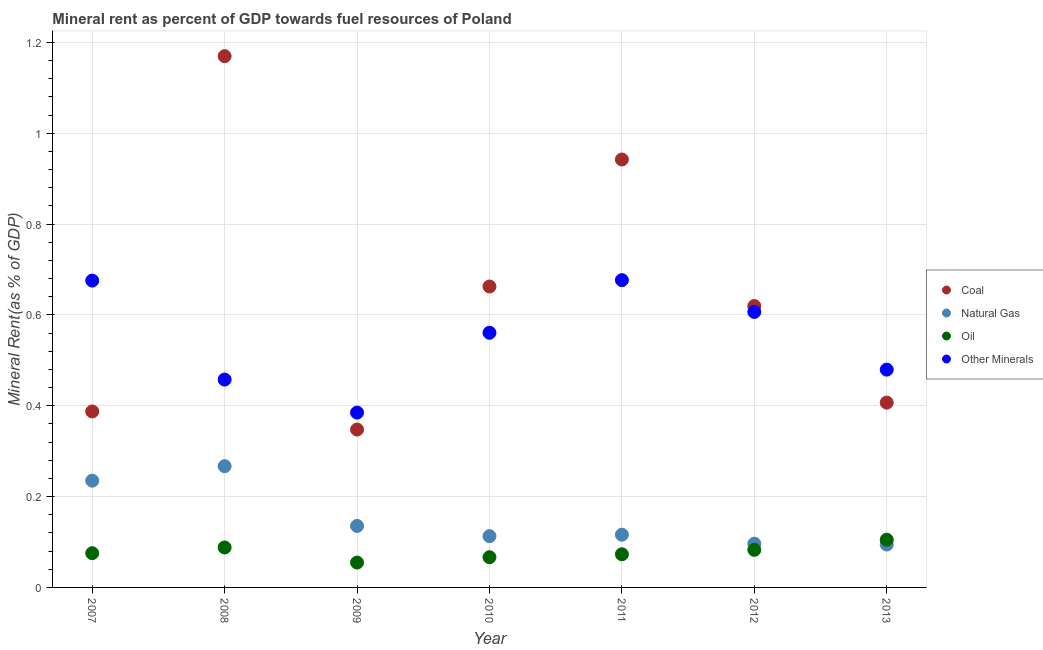How many different coloured dotlines are there?
Provide a short and direct response. 4. Is the number of dotlines equal to the number of legend labels?
Provide a succinct answer. Yes. What is the coal rent in 2007?
Provide a short and direct response. 0.39. Across all years, what is the maximum  rent of other minerals?
Provide a short and direct response. 0.68. Across all years, what is the minimum  rent of other minerals?
Provide a short and direct response. 0.39. In which year was the oil rent minimum?
Provide a succinct answer. 2009. What is the total oil rent in the graph?
Your answer should be compact. 0.55. What is the difference between the coal rent in 2010 and that in 2013?
Make the answer very short. 0.26. What is the difference between the  rent of other minerals in 2007 and the oil rent in 2012?
Offer a terse response. 0.59. What is the average oil rent per year?
Your response must be concise. 0.08. In the year 2007, what is the difference between the oil rent and coal rent?
Give a very brief answer. -0.31. In how many years, is the natural gas rent greater than 0.36 %?
Provide a short and direct response. 0. What is the ratio of the coal rent in 2008 to that in 2012?
Give a very brief answer. 1.89. What is the difference between the highest and the second highest natural gas rent?
Offer a terse response. 0.03. What is the difference between the highest and the lowest oil rent?
Your answer should be very brief. 0.05. In how many years, is the oil rent greater than the average oil rent taken over all years?
Your answer should be compact. 3. Is the sum of the  rent of other minerals in 2010 and 2011 greater than the maximum natural gas rent across all years?
Keep it short and to the point. Yes. Is it the case that in every year, the sum of the coal rent and natural gas rent is greater than the oil rent?
Keep it short and to the point. Yes. Does the coal rent monotonically increase over the years?
Ensure brevity in your answer.  No. Is the  rent of other minerals strictly greater than the coal rent over the years?
Make the answer very short. No. How many years are there in the graph?
Offer a very short reply. 7. Does the graph contain any zero values?
Your answer should be very brief. No. What is the title of the graph?
Your answer should be very brief. Mineral rent as percent of GDP towards fuel resources of Poland. Does "Quality Certification" appear as one of the legend labels in the graph?
Provide a short and direct response. No. What is the label or title of the Y-axis?
Ensure brevity in your answer.  Mineral Rent(as % of GDP). What is the Mineral Rent(as % of GDP) in Coal in 2007?
Your response must be concise. 0.39. What is the Mineral Rent(as % of GDP) of Natural Gas in 2007?
Your answer should be compact. 0.24. What is the Mineral Rent(as % of GDP) of Oil in 2007?
Give a very brief answer. 0.08. What is the Mineral Rent(as % of GDP) of Other Minerals in 2007?
Ensure brevity in your answer.  0.68. What is the Mineral Rent(as % of GDP) in Coal in 2008?
Provide a short and direct response. 1.17. What is the Mineral Rent(as % of GDP) of Natural Gas in 2008?
Offer a terse response. 0.27. What is the Mineral Rent(as % of GDP) of Oil in 2008?
Your response must be concise. 0.09. What is the Mineral Rent(as % of GDP) in Other Minerals in 2008?
Provide a succinct answer. 0.46. What is the Mineral Rent(as % of GDP) of Coal in 2009?
Offer a terse response. 0.35. What is the Mineral Rent(as % of GDP) of Natural Gas in 2009?
Keep it short and to the point. 0.14. What is the Mineral Rent(as % of GDP) of Oil in 2009?
Offer a terse response. 0.05. What is the Mineral Rent(as % of GDP) in Other Minerals in 2009?
Ensure brevity in your answer.  0.39. What is the Mineral Rent(as % of GDP) of Coal in 2010?
Provide a short and direct response. 0.66. What is the Mineral Rent(as % of GDP) in Natural Gas in 2010?
Make the answer very short. 0.11. What is the Mineral Rent(as % of GDP) in Oil in 2010?
Your response must be concise. 0.07. What is the Mineral Rent(as % of GDP) of Other Minerals in 2010?
Provide a short and direct response. 0.56. What is the Mineral Rent(as % of GDP) in Coal in 2011?
Provide a short and direct response. 0.94. What is the Mineral Rent(as % of GDP) in Natural Gas in 2011?
Your answer should be very brief. 0.12. What is the Mineral Rent(as % of GDP) of Oil in 2011?
Offer a very short reply. 0.07. What is the Mineral Rent(as % of GDP) of Other Minerals in 2011?
Ensure brevity in your answer.  0.68. What is the Mineral Rent(as % of GDP) of Coal in 2012?
Offer a very short reply. 0.62. What is the Mineral Rent(as % of GDP) in Natural Gas in 2012?
Keep it short and to the point. 0.1. What is the Mineral Rent(as % of GDP) of Oil in 2012?
Provide a succinct answer. 0.08. What is the Mineral Rent(as % of GDP) of Other Minerals in 2012?
Your response must be concise. 0.61. What is the Mineral Rent(as % of GDP) of Coal in 2013?
Your response must be concise. 0.41. What is the Mineral Rent(as % of GDP) of Natural Gas in 2013?
Make the answer very short. 0.09. What is the Mineral Rent(as % of GDP) of Oil in 2013?
Provide a succinct answer. 0.11. What is the Mineral Rent(as % of GDP) in Other Minerals in 2013?
Offer a very short reply. 0.48. Across all years, what is the maximum Mineral Rent(as % of GDP) in Coal?
Give a very brief answer. 1.17. Across all years, what is the maximum Mineral Rent(as % of GDP) in Natural Gas?
Offer a terse response. 0.27. Across all years, what is the maximum Mineral Rent(as % of GDP) in Oil?
Your response must be concise. 0.11. Across all years, what is the maximum Mineral Rent(as % of GDP) of Other Minerals?
Offer a very short reply. 0.68. Across all years, what is the minimum Mineral Rent(as % of GDP) of Coal?
Offer a very short reply. 0.35. Across all years, what is the minimum Mineral Rent(as % of GDP) in Natural Gas?
Give a very brief answer. 0.09. Across all years, what is the minimum Mineral Rent(as % of GDP) in Oil?
Give a very brief answer. 0.05. Across all years, what is the minimum Mineral Rent(as % of GDP) in Other Minerals?
Make the answer very short. 0.39. What is the total Mineral Rent(as % of GDP) of Coal in the graph?
Make the answer very short. 4.54. What is the total Mineral Rent(as % of GDP) of Natural Gas in the graph?
Your answer should be compact. 1.06. What is the total Mineral Rent(as % of GDP) of Oil in the graph?
Your response must be concise. 0.55. What is the total Mineral Rent(as % of GDP) in Other Minerals in the graph?
Your answer should be very brief. 3.84. What is the difference between the Mineral Rent(as % of GDP) in Coal in 2007 and that in 2008?
Your answer should be very brief. -0.78. What is the difference between the Mineral Rent(as % of GDP) in Natural Gas in 2007 and that in 2008?
Offer a very short reply. -0.03. What is the difference between the Mineral Rent(as % of GDP) in Oil in 2007 and that in 2008?
Offer a very short reply. -0.01. What is the difference between the Mineral Rent(as % of GDP) in Other Minerals in 2007 and that in 2008?
Give a very brief answer. 0.22. What is the difference between the Mineral Rent(as % of GDP) of Coal in 2007 and that in 2009?
Provide a short and direct response. 0.04. What is the difference between the Mineral Rent(as % of GDP) in Natural Gas in 2007 and that in 2009?
Provide a succinct answer. 0.1. What is the difference between the Mineral Rent(as % of GDP) of Oil in 2007 and that in 2009?
Offer a terse response. 0.02. What is the difference between the Mineral Rent(as % of GDP) in Other Minerals in 2007 and that in 2009?
Offer a very short reply. 0.29. What is the difference between the Mineral Rent(as % of GDP) of Coal in 2007 and that in 2010?
Your answer should be compact. -0.28. What is the difference between the Mineral Rent(as % of GDP) of Natural Gas in 2007 and that in 2010?
Your answer should be very brief. 0.12. What is the difference between the Mineral Rent(as % of GDP) in Oil in 2007 and that in 2010?
Make the answer very short. 0.01. What is the difference between the Mineral Rent(as % of GDP) in Other Minerals in 2007 and that in 2010?
Your answer should be very brief. 0.11. What is the difference between the Mineral Rent(as % of GDP) in Coal in 2007 and that in 2011?
Your answer should be compact. -0.55. What is the difference between the Mineral Rent(as % of GDP) in Natural Gas in 2007 and that in 2011?
Your answer should be compact. 0.12. What is the difference between the Mineral Rent(as % of GDP) of Oil in 2007 and that in 2011?
Ensure brevity in your answer.  0. What is the difference between the Mineral Rent(as % of GDP) in Other Minerals in 2007 and that in 2011?
Provide a short and direct response. -0. What is the difference between the Mineral Rent(as % of GDP) in Coal in 2007 and that in 2012?
Your response must be concise. -0.23. What is the difference between the Mineral Rent(as % of GDP) in Natural Gas in 2007 and that in 2012?
Your answer should be very brief. 0.14. What is the difference between the Mineral Rent(as % of GDP) in Oil in 2007 and that in 2012?
Make the answer very short. -0.01. What is the difference between the Mineral Rent(as % of GDP) of Other Minerals in 2007 and that in 2012?
Keep it short and to the point. 0.07. What is the difference between the Mineral Rent(as % of GDP) in Coal in 2007 and that in 2013?
Ensure brevity in your answer.  -0.02. What is the difference between the Mineral Rent(as % of GDP) in Natural Gas in 2007 and that in 2013?
Your response must be concise. 0.14. What is the difference between the Mineral Rent(as % of GDP) in Oil in 2007 and that in 2013?
Offer a terse response. -0.03. What is the difference between the Mineral Rent(as % of GDP) in Other Minerals in 2007 and that in 2013?
Offer a terse response. 0.2. What is the difference between the Mineral Rent(as % of GDP) of Coal in 2008 and that in 2009?
Provide a short and direct response. 0.82. What is the difference between the Mineral Rent(as % of GDP) in Natural Gas in 2008 and that in 2009?
Make the answer very short. 0.13. What is the difference between the Mineral Rent(as % of GDP) of Oil in 2008 and that in 2009?
Ensure brevity in your answer.  0.03. What is the difference between the Mineral Rent(as % of GDP) of Other Minerals in 2008 and that in 2009?
Keep it short and to the point. 0.07. What is the difference between the Mineral Rent(as % of GDP) of Coal in 2008 and that in 2010?
Make the answer very short. 0.51. What is the difference between the Mineral Rent(as % of GDP) in Natural Gas in 2008 and that in 2010?
Your answer should be very brief. 0.15. What is the difference between the Mineral Rent(as % of GDP) in Oil in 2008 and that in 2010?
Give a very brief answer. 0.02. What is the difference between the Mineral Rent(as % of GDP) in Other Minerals in 2008 and that in 2010?
Keep it short and to the point. -0.1. What is the difference between the Mineral Rent(as % of GDP) in Coal in 2008 and that in 2011?
Give a very brief answer. 0.23. What is the difference between the Mineral Rent(as % of GDP) of Natural Gas in 2008 and that in 2011?
Give a very brief answer. 0.15. What is the difference between the Mineral Rent(as % of GDP) of Oil in 2008 and that in 2011?
Provide a succinct answer. 0.01. What is the difference between the Mineral Rent(as % of GDP) in Other Minerals in 2008 and that in 2011?
Ensure brevity in your answer.  -0.22. What is the difference between the Mineral Rent(as % of GDP) in Coal in 2008 and that in 2012?
Ensure brevity in your answer.  0.55. What is the difference between the Mineral Rent(as % of GDP) of Natural Gas in 2008 and that in 2012?
Give a very brief answer. 0.17. What is the difference between the Mineral Rent(as % of GDP) of Oil in 2008 and that in 2012?
Keep it short and to the point. 0.01. What is the difference between the Mineral Rent(as % of GDP) of Other Minerals in 2008 and that in 2012?
Your answer should be very brief. -0.15. What is the difference between the Mineral Rent(as % of GDP) in Coal in 2008 and that in 2013?
Your answer should be compact. 0.76. What is the difference between the Mineral Rent(as % of GDP) of Natural Gas in 2008 and that in 2013?
Your answer should be compact. 0.17. What is the difference between the Mineral Rent(as % of GDP) in Oil in 2008 and that in 2013?
Offer a very short reply. -0.02. What is the difference between the Mineral Rent(as % of GDP) in Other Minerals in 2008 and that in 2013?
Provide a succinct answer. -0.02. What is the difference between the Mineral Rent(as % of GDP) in Coal in 2009 and that in 2010?
Your answer should be very brief. -0.32. What is the difference between the Mineral Rent(as % of GDP) of Natural Gas in 2009 and that in 2010?
Your answer should be compact. 0.02. What is the difference between the Mineral Rent(as % of GDP) in Oil in 2009 and that in 2010?
Provide a succinct answer. -0.01. What is the difference between the Mineral Rent(as % of GDP) of Other Minerals in 2009 and that in 2010?
Provide a succinct answer. -0.18. What is the difference between the Mineral Rent(as % of GDP) in Coal in 2009 and that in 2011?
Make the answer very short. -0.59. What is the difference between the Mineral Rent(as % of GDP) of Natural Gas in 2009 and that in 2011?
Your answer should be very brief. 0.02. What is the difference between the Mineral Rent(as % of GDP) in Oil in 2009 and that in 2011?
Your response must be concise. -0.02. What is the difference between the Mineral Rent(as % of GDP) of Other Minerals in 2009 and that in 2011?
Give a very brief answer. -0.29. What is the difference between the Mineral Rent(as % of GDP) in Coal in 2009 and that in 2012?
Offer a very short reply. -0.27. What is the difference between the Mineral Rent(as % of GDP) in Natural Gas in 2009 and that in 2012?
Keep it short and to the point. 0.04. What is the difference between the Mineral Rent(as % of GDP) of Oil in 2009 and that in 2012?
Your answer should be very brief. -0.03. What is the difference between the Mineral Rent(as % of GDP) in Other Minerals in 2009 and that in 2012?
Offer a very short reply. -0.22. What is the difference between the Mineral Rent(as % of GDP) in Coal in 2009 and that in 2013?
Give a very brief answer. -0.06. What is the difference between the Mineral Rent(as % of GDP) of Natural Gas in 2009 and that in 2013?
Provide a succinct answer. 0.04. What is the difference between the Mineral Rent(as % of GDP) of Oil in 2009 and that in 2013?
Provide a short and direct response. -0.05. What is the difference between the Mineral Rent(as % of GDP) of Other Minerals in 2009 and that in 2013?
Keep it short and to the point. -0.09. What is the difference between the Mineral Rent(as % of GDP) in Coal in 2010 and that in 2011?
Provide a succinct answer. -0.28. What is the difference between the Mineral Rent(as % of GDP) of Natural Gas in 2010 and that in 2011?
Your answer should be very brief. -0. What is the difference between the Mineral Rent(as % of GDP) of Oil in 2010 and that in 2011?
Give a very brief answer. -0.01. What is the difference between the Mineral Rent(as % of GDP) in Other Minerals in 2010 and that in 2011?
Offer a terse response. -0.12. What is the difference between the Mineral Rent(as % of GDP) of Coal in 2010 and that in 2012?
Offer a terse response. 0.04. What is the difference between the Mineral Rent(as % of GDP) in Natural Gas in 2010 and that in 2012?
Make the answer very short. 0.02. What is the difference between the Mineral Rent(as % of GDP) in Oil in 2010 and that in 2012?
Offer a terse response. -0.02. What is the difference between the Mineral Rent(as % of GDP) in Other Minerals in 2010 and that in 2012?
Offer a very short reply. -0.05. What is the difference between the Mineral Rent(as % of GDP) in Coal in 2010 and that in 2013?
Offer a very short reply. 0.26. What is the difference between the Mineral Rent(as % of GDP) in Natural Gas in 2010 and that in 2013?
Your answer should be very brief. 0.02. What is the difference between the Mineral Rent(as % of GDP) of Oil in 2010 and that in 2013?
Give a very brief answer. -0.04. What is the difference between the Mineral Rent(as % of GDP) in Other Minerals in 2010 and that in 2013?
Your answer should be very brief. 0.08. What is the difference between the Mineral Rent(as % of GDP) in Coal in 2011 and that in 2012?
Your answer should be very brief. 0.32. What is the difference between the Mineral Rent(as % of GDP) of Natural Gas in 2011 and that in 2012?
Make the answer very short. 0.02. What is the difference between the Mineral Rent(as % of GDP) of Oil in 2011 and that in 2012?
Ensure brevity in your answer.  -0.01. What is the difference between the Mineral Rent(as % of GDP) of Other Minerals in 2011 and that in 2012?
Keep it short and to the point. 0.07. What is the difference between the Mineral Rent(as % of GDP) of Coal in 2011 and that in 2013?
Make the answer very short. 0.54. What is the difference between the Mineral Rent(as % of GDP) of Natural Gas in 2011 and that in 2013?
Your response must be concise. 0.02. What is the difference between the Mineral Rent(as % of GDP) in Oil in 2011 and that in 2013?
Your response must be concise. -0.03. What is the difference between the Mineral Rent(as % of GDP) in Other Minerals in 2011 and that in 2013?
Your response must be concise. 0.2. What is the difference between the Mineral Rent(as % of GDP) in Coal in 2012 and that in 2013?
Your answer should be compact. 0.21. What is the difference between the Mineral Rent(as % of GDP) in Natural Gas in 2012 and that in 2013?
Your answer should be very brief. 0. What is the difference between the Mineral Rent(as % of GDP) in Oil in 2012 and that in 2013?
Keep it short and to the point. -0.02. What is the difference between the Mineral Rent(as % of GDP) in Other Minerals in 2012 and that in 2013?
Offer a terse response. 0.13. What is the difference between the Mineral Rent(as % of GDP) of Coal in 2007 and the Mineral Rent(as % of GDP) of Natural Gas in 2008?
Provide a succinct answer. 0.12. What is the difference between the Mineral Rent(as % of GDP) of Coal in 2007 and the Mineral Rent(as % of GDP) of Oil in 2008?
Make the answer very short. 0.3. What is the difference between the Mineral Rent(as % of GDP) in Coal in 2007 and the Mineral Rent(as % of GDP) in Other Minerals in 2008?
Provide a succinct answer. -0.07. What is the difference between the Mineral Rent(as % of GDP) of Natural Gas in 2007 and the Mineral Rent(as % of GDP) of Oil in 2008?
Give a very brief answer. 0.15. What is the difference between the Mineral Rent(as % of GDP) of Natural Gas in 2007 and the Mineral Rent(as % of GDP) of Other Minerals in 2008?
Offer a terse response. -0.22. What is the difference between the Mineral Rent(as % of GDP) in Oil in 2007 and the Mineral Rent(as % of GDP) in Other Minerals in 2008?
Ensure brevity in your answer.  -0.38. What is the difference between the Mineral Rent(as % of GDP) of Coal in 2007 and the Mineral Rent(as % of GDP) of Natural Gas in 2009?
Make the answer very short. 0.25. What is the difference between the Mineral Rent(as % of GDP) in Coal in 2007 and the Mineral Rent(as % of GDP) in Oil in 2009?
Provide a short and direct response. 0.33. What is the difference between the Mineral Rent(as % of GDP) in Coal in 2007 and the Mineral Rent(as % of GDP) in Other Minerals in 2009?
Your answer should be compact. 0. What is the difference between the Mineral Rent(as % of GDP) of Natural Gas in 2007 and the Mineral Rent(as % of GDP) of Oil in 2009?
Offer a terse response. 0.18. What is the difference between the Mineral Rent(as % of GDP) of Natural Gas in 2007 and the Mineral Rent(as % of GDP) of Other Minerals in 2009?
Your answer should be very brief. -0.15. What is the difference between the Mineral Rent(as % of GDP) in Oil in 2007 and the Mineral Rent(as % of GDP) in Other Minerals in 2009?
Your response must be concise. -0.31. What is the difference between the Mineral Rent(as % of GDP) of Coal in 2007 and the Mineral Rent(as % of GDP) of Natural Gas in 2010?
Ensure brevity in your answer.  0.27. What is the difference between the Mineral Rent(as % of GDP) of Coal in 2007 and the Mineral Rent(as % of GDP) of Oil in 2010?
Your answer should be very brief. 0.32. What is the difference between the Mineral Rent(as % of GDP) in Coal in 2007 and the Mineral Rent(as % of GDP) in Other Minerals in 2010?
Make the answer very short. -0.17. What is the difference between the Mineral Rent(as % of GDP) in Natural Gas in 2007 and the Mineral Rent(as % of GDP) in Oil in 2010?
Ensure brevity in your answer.  0.17. What is the difference between the Mineral Rent(as % of GDP) of Natural Gas in 2007 and the Mineral Rent(as % of GDP) of Other Minerals in 2010?
Keep it short and to the point. -0.33. What is the difference between the Mineral Rent(as % of GDP) of Oil in 2007 and the Mineral Rent(as % of GDP) of Other Minerals in 2010?
Your answer should be compact. -0.49. What is the difference between the Mineral Rent(as % of GDP) in Coal in 2007 and the Mineral Rent(as % of GDP) in Natural Gas in 2011?
Give a very brief answer. 0.27. What is the difference between the Mineral Rent(as % of GDP) of Coal in 2007 and the Mineral Rent(as % of GDP) of Oil in 2011?
Give a very brief answer. 0.31. What is the difference between the Mineral Rent(as % of GDP) in Coal in 2007 and the Mineral Rent(as % of GDP) in Other Minerals in 2011?
Your answer should be compact. -0.29. What is the difference between the Mineral Rent(as % of GDP) of Natural Gas in 2007 and the Mineral Rent(as % of GDP) of Oil in 2011?
Your answer should be very brief. 0.16. What is the difference between the Mineral Rent(as % of GDP) of Natural Gas in 2007 and the Mineral Rent(as % of GDP) of Other Minerals in 2011?
Provide a short and direct response. -0.44. What is the difference between the Mineral Rent(as % of GDP) of Oil in 2007 and the Mineral Rent(as % of GDP) of Other Minerals in 2011?
Keep it short and to the point. -0.6. What is the difference between the Mineral Rent(as % of GDP) of Coal in 2007 and the Mineral Rent(as % of GDP) of Natural Gas in 2012?
Ensure brevity in your answer.  0.29. What is the difference between the Mineral Rent(as % of GDP) in Coal in 2007 and the Mineral Rent(as % of GDP) in Oil in 2012?
Keep it short and to the point. 0.3. What is the difference between the Mineral Rent(as % of GDP) in Coal in 2007 and the Mineral Rent(as % of GDP) in Other Minerals in 2012?
Provide a succinct answer. -0.22. What is the difference between the Mineral Rent(as % of GDP) in Natural Gas in 2007 and the Mineral Rent(as % of GDP) in Oil in 2012?
Offer a terse response. 0.15. What is the difference between the Mineral Rent(as % of GDP) of Natural Gas in 2007 and the Mineral Rent(as % of GDP) of Other Minerals in 2012?
Your answer should be very brief. -0.37. What is the difference between the Mineral Rent(as % of GDP) of Oil in 2007 and the Mineral Rent(as % of GDP) of Other Minerals in 2012?
Provide a short and direct response. -0.53. What is the difference between the Mineral Rent(as % of GDP) of Coal in 2007 and the Mineral Rent(as % of GDP) of Natural Gas in 2013?
Provide a succinct answer. 0.29. What is the difference between the Mineral Rent(as % of GDP) of Coal in 2007 and the Mineral Rent(as % of GDP) of Oil in 2013?
Make the answer very short. 0.28. What is the difference between the Mineral Rent(as % of GDP) in Coal in 2007 and the Mineral Rent(as % of GDP) in Other Minerals in 2013?
Your response must be concise. -0.09. What is the difference between the Mineral Rent(as % of GDP) in Natural Gas in 2007 and the Mineral Rent(as % of GDP) in Oil in 2013?
Make the answer very short. 0.13. What is the difference between the Mineral Rent(as % of GDP) of Natural Gas in 2007 and the Mineral Rent(as % of GDP) of Other Minerals in 2013?
Give a very brief answer. -0.24. What is the difference between the Mineral Rent(as % of GDP) of Oil in 2007 and the Mineral Rent(as % of GDP) of Other Minerals in 2013?
Provide a short and direct response. -0.4. What is the difference between the Mineral Rent(as % of GDP) in Coal in 2008 and the Mineral Rent(as % of GDP) in Natural Gas in 2009?
Provide a short and direct response. 1.03. What is the difference between the Mineral Rent(as % of GDP) in Coal in 2008 and the Mineral Rent(as % of GDP) in Oil in 2009?
Your answer should be compact. 1.12. What is the difference between the Mineral Rent(as % of GDP) of Coal in 2008 and the Mineral Rent(as % of GDP) of Other Minerals in 2009?
Offer a terse response. 0.78. What is the difference between the Mineral Rent(as % of GDP) in Natural Gas in 2008 and the Mineral Rent(as % of GDP) in Oil in 2009?
Keep it short and to the point. 0.21. What is the difference between the Mineral Rent(as % of GDP) in Natural Gas in 2008 and the Mineral Rent(as % of GDP) in Other Minerals in 2009?
Your answer should be compact. -0.12. What is the difference between the Mineral Rent(as % of GDP) of Oil in 2008 and the Mineral Rent(as % of GDP) of Other Minerals in 2009?
Your response must be concise. -0.3. What is the difference between the Mineral Rent(as % of GDP) of Coal in 2008 and the Mineral Rent(as % of GDP) of Natural Gas in 2010?
Your response must be concise. 1.06. What is the difference between the Mineral Rent(as % of GDP) in Coal in 2008 and the Mineral Rent(as % of GDP) in Oil in 2010?
Ensure brevity in your answer.  1.1. What is the difference between the Mineral Rent(as % of GDP) in Coal in 2008 and the Mineral Rent(as % of GDP) in Other Minerals in 2010?
Ensure brevity in your answer.  0.61. What is the difference between the Mineral Rent(as % of GDP) in Natural Gas in 2008 and the Mineral Rent(as % of GDP) in Oil in 2010?
Offer a very short reply. 0.2. What is the difference between the Mineral Rent(as % of GDP) in Natural Gas in 2008 and the Mineral Rent(as % of GDP) in Other Minerals in 2010?
Your answer should be very brief. -0.29. What is the difference between the Mineral Rent(as % of GDP) of Oil in 2008 and the Mineral Rent(as % of GDP) of Other Minerals in 2010?
Your response must be concise. -0.47. What is the difference between the Mineral Rent(as % of GDP) of Coal in 2008 and the Mineral Rent(as % of GDP) of Natural Gas in 2011?
Give a very brief answer. 1.05. What is the difference between the Mineral Rent(as % of GDP) in Coal in 2008 and the Mineral Rent(as % of GDP) in Oil in 2011?
Keep it short and to the point. 1.1. What is the difference between the Mineral Rent(as % of GDP) of Coal in 2008 and the Mineral Rent(as % of GDP) of Other Minerals in 2011?
Provide a short and direct response. 0.49. What is the difference between the Mineral Rent(as % of GDP) in Natural Gas in 2008 and the Mineral Rent(as % of GDP) in Oil in 2011?
Your response must be concise. 0.19. What is the difference between the Mineral Rent(as % of GDP) of Natural Gas in 2008 and the Mineral Rent(as % of GDP) of Other Minerals in 2011?
Ensure brevity in your answer.  -0.41. What is the difference between the Mineral Rent(as % of GDP) of Oil in 2008 and the Mineral Rent(as % of GDP) of Other Minerals in 2011?
Give a very brief answer. -0.59. What is the difference between the Mineral Rent(as % of GDP) in Coal in 2008 and the Mineral Rent(as % of GDP) in Natural Gas in 2012?
Provide a succinct answer. 1.07. What is the difference between the Mineral Rent(as % of GDP) of Coal in 2008 and the Mineral Rent(as % of GDP) of Oil in 2012?
Keep it short and to the point. 1.09. What is the difference between the Mineral Rent(as % of GDP) in Coal in 2008 and the Mineral Rent(as % of GDP) in Other Minerals in 2012?
Offer a very short reply. 0.56. What is the difference between the Mineral Rent(as % of GDP) of Natural Gas in 2008 and the Mineral Rent(as % of GDP) of Oil in 2012?
Ensure brevity in your answer.  0.18. What is the difference between the Mineral Rent(as % of GDP) in Natural Gas in 2008 and the Mineral Rent(as % of GDP) in Other Minerals in 2012?
Your response must be concise. -0.34. What is the difference between the Mineral Rent(as % of GDP) of Oil in 2008 and the Mineral Rent(as % of GDP) of Other Minerals in 2012?
Make the answer very short. -0.52. What is the difference between the Mineral Rent(as % of GDP) in Coal in 2008 and the Mineral Rent(as % of GDP) in Natural Gas in 2013?
Make the answer very short. 1.08. What is the difference between the Mineral Rent(as % of GDP) in Coal in 2008 and the Mineral Rent(as % of GDP) in Oil in 2013?
Give a very brief answer. 1.06. What is the difference between the Mineral Rent(as % of GDP) in Coal in 2008 and the Mineral Rent(as % of GDP) in Other Minerals in 2013?
Offer a very short reply. 0.69. What is the difference between the Mineral Rent(as % of GDP) of Natural Gas in 2008 and the Mineral Rent(as % of GDP) of Oil in 2013?
Provide a succinct answer. 0.16. What is the difference between the Mineral Rent(as % of GDP) of Natural Gas in 2008 and the Mineral Rent(as % of GDP) of Other Minerals in 2013?
Give a very brief answer. -0.21. What is the difference between the Mineral Rent(as % of GDP) of Oil in 2008 and the Mineral Rent(as % of GDP) of Other Minerals in 2013?
Offer a terse response. -0.39. What is the difference between the Mineral Rent(as % of GDP) of Coal in 2009 and the Mineral Rent(as % of GDP) of Natural Gas in 2010?
Provide a succinct answer. 0.23. What is the difference between the Mineral Rent(as % of GDP) of Coal in 2009 and the Mineral Rent(as % of GDP) of Oil in 2010?
Your answer should be compact. 0.28. What is the difference between the Mineral Rent(as % of GDP) in Coal in 2009 and the Mineral Rent(as % of GDP) in Other Minerals in 2010?
Give a very brief answer. -0.21. What is the difference between the Mineral Rent(as % of GDP) in Natural Gas in 2009 and the Mineral Rent(as % of GDP) in Oil in 2010?
Keep it short and to the point. 0.07. What is the difference between the Mineral Rent(as % of GDP) in Natural Gas in 2009 and the Mineral Rent(as % of GDP) in Other Minerals in 2010?
Provide a succinct answer. -0.43. What is the difference between the Mineral Rent(as % of GDP) of Oil in 2009 and the Mineral Rent(as % of GDP) of Other Minerals in 2010?
Provide a succinct answer. -0.51. What is the difference between the Mineral Rent(as % of GDP) in Coal in 2009 and the Mineral Rent(as % of GDP) in Natural Gas in 2011?
Keep it short and to the point. 0.23. What is the difference between the Mineral Rent(as % of GDP) of Coal in 2009 and the Mineral Rent(as % of GDP) of Oil in 2011?
Offer a very short reply. 0.27. What is the difference between the Mineral Rent(as % of GDP) of Coal in 2009 and the Mineral Rent(as % of GDP) of Other Minerals in 2011?
Ensure brevity in your answer.  -0.33. What is the difference between the Mineral Rent(as % of GDP) of Natural Gas in 2009 and the Mineral Rent(as % of GDP) of Oil in 2011?
Provide a short and direct response. 0.06. What is the difference between the Mineral Rent(as % of GDP) in Natural Gas in 2009 and the Mineral Rent(as % of GDP) in Other Minerals in 2011?
Ensure brevity in your answer.  -0.54. What is the difference between the Mineral Rent(as % of GDP) in Oil in 2009 and the Mineral Rent(as % of GDP) in Other Minerals in 2011?
Give a very brief answer. -0.62. What is the difference between the Mineral Rent(as % of GDP) of Coal in 2009 and the Mineral Rent(as % of GDP) of Natural Gas in 2012?
Offer a terse response. 0.25. What is the difference between the Mineral Rent(as % of GDP) in Coal in 2009 and the Mineral Rent(as % of GDP) in Oil in 2012?
Give a very brief answer. 0.26. What is the difference between the Mineral Rent(as % of GDP) of Coal in 2009 and the Mineral Rent(as % of GDP) of Other Minerals in 2012?
Ensure brevity in your answer.  -0.26. What is the difference between the Mineral Rent(as % of GDP) of Natural Gas in 2009 and the Mineral Rent(as % of GDP) of Oil in 2012?
Your response must be concise. 0.05. What is the difference between the Mineral Rent(as % of GDP) in Natural Gas in 2009 and the Mineral Rent(as % of GDP) in Other Minerals in 2012?
Provide a succinct answer. -0.47. What is the difference between the Mineral Rent(as % of GDP) of Oil in 2009 and the Mineral Rent(as % of GDP) of Other Minerals in 2012?
Give a very brief answer. -0.55. What is the difference between the Mineral Rent(as % of GDP) of Coal in 2009 and the Mineral Rent(as % of GDP) of Natural Gas in 2013?
Keep it short and to the point. 0.25. What is the difference between the Mineral Rent(as % of GDP) in Coal in 2009 and the Mineral Rent(as % of GDP) in Oil in 2013?
Offer a very short reply. 0.24. What is the difference between the Mineral Rent(as % of GDP) of Coal in 2009 and the Mineral Rent(as % of GDP) of Other Minerals in 2013?
Keep it short and to the point. -0.13. What is the difference between the Mineral Rent(as % of GDP) in Natural Gas in 2009 and the Mineral Rent(as % of GDP) in Oil in 2013?
Make the answer very short. 0.03. What is the difference between the Mineral Rent(as % of GDP) in Natural Gas in 2009 and the Mineral Rent(as % of GDP) in Other Minerals in 2013?
Your response must be concise. -0.34. What is the difference between the Mineral Rent(as % of GDP) in Oil in 2009 and the Mineral Rent(as % of GDP) in Other Minerals in 2013?
Your response must be concise. -0.42. What is the difference between the Mineral Rent(as % of GDP) of Coal in 2010 and the Mineral Rent(as % of GDP) of Natural Gas in 2011?
Give a very brief answer. 0.55. What is the difference between the Mineral Rent(as % of GDP) of Coal in 2010 and the Mineral Rent(as % of GDP) of Oil in 2011?
Your answer should be compact. 0.59. What is the difference between the Mineral Rent(as % of GDP) of Coal in 2010 and the Mineral Rent(as % of GDP) of Other Minerals in 2011?
Your response must be concise. -0.01. What is the difference between the Mineral Rent(as % of GDP) of Natural Gas in 2010 and the Mineral Rent(as % of GDP) of Oil in 2011?
Provide a succinct answer. 0.04. What is the difference between the Mineral Rent(as % of GDP) of Natural Gas in 2010 and the Mineral Rent(as % of GDP) of Other Minerals in 2011?
Offer a terse response. -0.56. What is the difference between the Mineral Rent(as % of GDP) of Oil in 2010 and the Mineral Rent(as % of GDP) of Other Minerals in 2011?
Give a very brief answer. -0.61. What is the difference between the Mineral Rent(as % of GDP) in Coal in 2010 and the Mineral Rent(as % of GDP) in Natural Gas in 2012?
Your answer should be compact. 0.57. What is the difference between the Mineral Rent(as % of GDP) in Coal in 2010 and the Mineral Rent(as % of GDP) in Oil in 2012?
Your answer should be very brief. 0.58. What is the difference between the Mineral Rent(as % of GDP) in Coal in 2010 and the Mineral Rent(as % of GDP) in Other Minerals in 2012?
Offer a terse response. 0.06. What is the difference between the Mineral Rent(as % of GDP) of Natural Gas in 2010 and the Mineral Rent(as % of GDP) of Oil in 2012?
Offer a very short reply. 0.03. What is the difference between the Mineral Rent(as % of GDP) of Natural Gas in 2010 and the Mineral Rent(as % of GDP) of Other Minerals in 2012?
Make the answer very short. -0.49. What is the difference between the Mineral Rent(as % of GDP) of Oil in 2010 and the Mineral Rent(as % of GDP) of Other Minerals in 2012?
Offer a terse response. -0.54. What is the difference between the Mineral Rent(as % of GDP) in Coal in 2010 and the Mineral Rent(as % of GDP) in Natural Gas in 2013?
Offer a terse response. 0.57. What is the difference between the Mineral Rent(as % of GDP) of Coal in 2010 and the Mineral Rent(as % of GDP) of Oil in 2013?
Keep it short and to the point. 0.56. What is the difference between the Mineral Rent(as % of GDP) in Coal in 2010 and the Mineral Rent(as % of GDP) in Other Minerals in 2013?
Your answer should be very brief. 0.18. What is the difference between the Mineral Rent(as % of GDP) of Natural Gas in 2010 and the Mineral Rent(as % of GDP) of Oil in 2013?
Make the answer very short. 0.01. What is the difference between the Mineral Rent(as % of GDP) of Natural Gas in 2010 and the Mineral Rent(as % of GDP) of Other Minerals in 2013?
Provide a short and direct response. -0.37. What is the difference between the Mineral Rent(as % of GDP) of Oil in 2010 and the Mineral Rent(as % of GDP) of Other Minerals in 2013?
Offer a terse response. -0.41. What is the difference between the Mineral Rent(as % of GDP) of Coal in 2011 and the Mineral Rent(as % of GDP) of Natural Gas in 2012?
Make the answer very short. 0.85. What is the difference between the Mineral Rent(as % of GDP) in Coal in 2011 and the Mineral Rent(as % of GDP) in Oil in 2012?
Keep it short and to the point. 0.86. What is the difference between the Mineral Rent(as % of GDP) of Coal in 2011 and the Mineral Rent(as % of GDP) of Other Minerals in 2012?
Make the answer very short. 0.34. What is the difference between the Mineral Rent(as % of GDP) in Natural Gas in 2011 and the Mineral Rent(as % of GDP) in Oil in 2012?
Offer a very short reply. 0.03. What is the difference between the Mineral Rent(as % of GDP) in Natural Gas in 2011 and the Mineral Rent(as % of GDP) in Other Minerals in 2012?
Your response must be concise. -0.49. What is the difference between the Mineral Rent(as % of GDP) of Oil in 2011 and the Mineral Rent(as % of GDP) of Other Minerals in 2012?
Your answer should be very brief. -0.53. What is the difference between the Mineral Rent(as % of GDP) of Coal in 2011 and the Mineral Rent(as % of GDP) of Natural Gas in 2013?
Keep it short and to the point. 0.85. What is the difference between the Mineral Rent(as % of GDP) of Coal in 2011 and the Mineral Rent(as % of GDP) of Oil in 2013?
Your response must be concise. 0.84. What is the difference between the Mineral Rent(as % of GDP) in Coal in 2011 and the Mineral Rent(as % of GDP) in Other Minerals in 2013?
Give a very brief answer. 0.46. What is the difference between the Mineral Rent(as % of GDP) in Natural Gas in 2011 and the Mineral Rent(as % of GDP) in Oil in 2013?
Offer a very short reply. 0.01. What is the difference between the Mineral Rent(as % of GDP) in Natural Gas in 2011 and the Mineral Rent(as % of GDP) in Other Minerals in 2013?
Ensure brevity in your answer.  -0.36. What is the difference between the Mineral Rent(as % of GDP) in Oil in 2011 and the Mineral Rent(as % of GDP) in Other Minerals in 2013?
Ensure brevity in your answer.  -0.41. What is the difference between the Mineral Rent(as % of GDP) in Coal in 2012 and the Mineral Rent(as % of GDP) in Natural Gas in 2013?
Offer a very short reply. 0.53. What is the difference between the Mineral Rent(as % of GDP) in Coal in 2012 and the Mineral Rent(as % of GDP) in Oil in 2013?
Provide a succinct answer. 0.51. What is the difference between the Mineral Rent(as % of GDP) in Coal in 2012 and the Mineral Rent(as % of GDP) in Other Minerals in 2013?
Your answer should be compact. 0.14. What is the difference between the Mineral Rent(as % of GDP) of Natural Gas in 2012 and the Mineral Rent(as % of GDP) of Oil in 2013?
Provide a succinct answer. -0.01. What is the difference between the Mineral Rent(as % of GDP) of Natural Gas in 2012 and the Mineral Rent(as % of GDP) of Other Minerals in 2013?
Provide a short and direct response. -0.38. What is the difference between the Mineral Rent(as % of GDP) in Oil in 2012 and the Mineral Rent(as % of GDP) in Other Minerals in 2013?
Your response must be concise. -0.4. What is the average Mineral Rent(as % of GDP) in Coal per year?
Ensure brevity in your answer.  0.65. What is the average Mineral Rent(as % of GDP) of Natural Gas per year?
Your response must be concise. 0.15. What is the average Mineral Rent(as % of GDP) in Oil per year?
Provide a short and direct response. 0.08. What is the average Mineral Rent(as % of GDP) of Other Minerals per year?
Give a very brief answer. 0.55. In the year 2007, what is the difference between the Mineral Rent(as % of GDP) in Coal and Mineral Rent(as % of GDP) in Natural Gas?
Ensure brevity in your answer.  0.15. In the year 2007, what is the difference between the Mineral Rent(as % of GDP) in Coal and Mineral Rent(as % of GDP) in Oil?
Provide a short and direct response. 0.31. In the year 2007, what is the difference between the Mineral Rent(as % of GDP) of Coal and Mineral Rent(as % of GDP) of Other Minerals?
Provide a short and direct response. -0.29. In the year 2007, what is the difference between the Mineral Rent(as % of GDP) of Natural Gas and Mineral Rent(as % of GDP) of Oil?
Keep it short and to the point. 0.16. In the year 2007, what is the difference between the Mineral Rent(as % of GDP) of Natural Gas and Mineral Rent(as % of GDP) of Other Minerals?
Your answer should be compact. -0.44. In the year 2007, what is the difference between the Mineral Rent(as % of GDP) in Oil and Mineral Rent(as % of GDP) in Other Minerals?
Keep it short and to the point. -0.6. In the year 2008, what is the difference between the Mineral Rent(as % of GDP) in Coal and Mineral Rent(as % of GDP) in Natural Gas?
Provide a short and direct response. 0.9. In the year 2008, what is the difference between the Mineral Rent(as % of GDP) of Coal and Mineral Rent(as % of GDP) of Oil?
Make the answer very short. 1.08. In the year 2008, what is the difference between the Mineral Rent(as % of GDP) in Coal and Mineral Rent(as % of GDP) in Other Minerals?
Keep it short and to the point. 0.71. In the year 2008, what is the difference between the Mineral Rent(as % of GDP) in Natural Gas and Mineral Rent(as % of GDP) in Oil?
Provide a succinct answer. 0.18. In the year 2008, what is the difference between the Mineral Rent(as % of GDP) in Natural Gas and Mineral Rent(as % of GDP) in Other Minerals?
Your response must be concise. -0.19. In the year 2008, what is the difference between the Mineral Rent(as % of GDP) of Oil and Mineral Rent(as % of GDP) of Other Minerals?
Provide a succinct answer. -0.37. In the year 2009, what is the difference between the Mineral Rent(as % of GDP) in Coal and Mineral Rent(as % of GDP) in Natural Gas?
Provide a succinct answer. 0.21. In the year 2009, what is the difference between the Mineral Rent(as % of GDP) in Coal and Mineral Rent(as % of GDP) in Oil?
Offer a very short reply. 0.29. In the year 2009, what is the difference between the Mineral Rent(as % of GDP) of Coal and Mineral Rent(as % of GDP) of Other Minerals?
Your response must be concise. -0.04. In the year 2009, what is the difference between the Mineral Rent(as % of GDP) of Natural Gas and Mineral Rent(as % of GDP) of Oil?
Offer a very short reply. 0.08. In the year 2009, what is the difference between the Mineral Rent(as % of GDP) in Natural Gas and Mineral Rent(as % of GDP) in Other Minerals?
Ensure brevity in your answer.  -0.25. In the year 2009, what is the difference between the Mineral Rent(as % of GDP) in Oil and Mineral Rent(as % of GDP) in Other Minerals?
Your answer should be very brief. -0.33. In the year 2010, what is the difference between the Mineral Rent(as % of GDP) in Coal and Mineral Rent(as % of GDP) in Natural Gas?
Provide a short and direct response. 0.55. In the year 2010, what is the difference between the Mineral Rent(as % of GDP) in Coal and Mineral Rent(as % of GDP) in Oil?
Your answer should be compact. 0.6. In the year 2010, what is the difference between the Mineral Rent(as % of GDP) in Coal and Mineral Rent(as % of GDP) in Other Minerals?
Make the answer very short. 0.1. In the year 2010, what is the difference between the Mineral Rent(as % of GDP) of Natural Gas and Mineral Rent(as % of GDP) of Oil?
Offer a terse response. 0.05. In the year 2010, what is the difference between the Mineral Rent(as % of GDP) in Natural Gas and Mineral Rent(as % of GDP) in Other Minerals?
Make the answer very short. -0.45. In the year 2010, what is the difference between the Mineral Rent(as % of GDP) of Oil and Mineral Rent(as % of GDP) of Other Minerals?
Ensure brevity in your answer.  -0.49. In the year 2011, what is the difference between the Mineral Rent(as % of GDP) of Coal and Mineral Rent(as % of GDP) of Natural Gas?
Your answer should be compact. 0.83. In the year 2011, what is the difference between the Mineral Rent(as % of GDP) in Coal and Mineral Rent(as % of GDP) in Oil?
Make the answer very short. 0.87. In the year 2011, what is the difference between the Mineral Rent(as % of GDP) in Coal and Mineral Rent(as % of GDP) in Other Minerals?
Keep it short and to the point. 0.27. In the year 2011, what is the difference between the Mineral Rent(as % of GDP) in Natural Gas and Mineral Rent(as % of GDP) in Oil?
Your answer should be compact. 0.04. In the year 2011, what is the difference between the Mineral Rent(as % of GDP) in Natural Gas and Mineral Rent(as % of GDP) in Other Minerals?
Offer a terse response. -0.56. In the year 2011, what is the difference between the Mineral Rent(as % of GDP) in Oil and Mineral Rent(as % of GDP) in Other Minerals?
Make the answer very short. -0.6. In the year 2012, what is the difference between the Mineral Rent(as % of GDP) of Coal and Mineral Rent(as % of GDP) of Natural Gas?
Provide a succinct answer. 0.52. In the year 2012, what is the difference between the Mineral Rent(as % of GDP) of Coal and Mineral Rent(as % of GDP) of Oil?
Give a very brief answer. 0.54. In the year 2012, what is the difference between the Mineral Rent(as % of GDP) in Coal and Mineral Rent(as % of GDP) in Other Minerals?
Your answer should be very brief. 0.01. In the year 2012, what is the difference between the Mineral Rent(as % of GDP) in Natural Gas and Mineral Rent(as % of GDP) in Oil?
Your answer should be compact. 0.01. In the year 2012, what is the difference between the Mineral Rent(as % of GDP) of Natural Gas and Mineral Rent(as % of GDP) of Other Minerals?
Offer a terse response. -0.51. In the year 2012, what is the difference between the Mineral Rent(as % of GDP) of Oil and Mineral Rent(as % of GDP) of Other Minerals?
Ensure brevity in your answer.  -0.52. In the year 2013, what is the difference between the Mineral Rent(as % of GDP) in Coal and Mineral Rent(as % of GDP) in Natural Gas?
Your answer should be very brief. 0.31. In the year 2013, what is the difference between the Mineral Rent(as % of GDP) in Coal and Mineral Rent(as % of GDP) in Oil?
Make the answer very short. 0.3. In the year 2013, what is the difference between the Mineral Rent(as % of GDP) in Coal and Mineral Rent(as % of GDP) in Other Minerals?
Keep it short and to the point. -0.07. In the year 2013, what is the difference between the Mineral Rent(as % of GDP) of Natural Gas and Mineral Rent(as % of GDP) of Oil?
Offer a very short reply. -0.01. In the year 2013, what is the difference between the Mineral Rent(as % of GDP) in Natural Gas and Mineral Rent(as % of GDP) in Other Minerals?
Ensure brevity in your answer.  -0.39. In the year 2013, what is the difference between the Mineral Rent(as % of GDP) of Oil and Mineral Rent(as % of GDP) of Other Minerals?
Provide a succinct answer. -0.37. What is the ratio of the Mineral Rent(as % of GDP) of Coal in 2007 to that in 2008?
Your answer should be compact. 0.33. What is the ratio of the Mineral Rent(as % of GDP) of Natural Gas in 2007 to that in 2008?
Your answer should be compact. 0.88. What is the ratio of the Mineral Rent(as % of GDP) of Oil in 2007 to that in 2008?
Your answer should be very brief. 0.86. What is the ratio of the Mineral Rent(as % of GDP) of Other Minerals in 2007 to that in 2008?
Offer a terse response. 1.48. What is the ratio of the Mineral Rent(as % of GDP) in Coal in 2007 to that in 2009?
Your response must be concise. 1.11. What is the ratio of the Mineral Rent(as % of GDP) in Natural Gas in 2007 to that in 2009?
Ensure brevity in your answer.  1.74. What is the ratio of the Mineral Rent(as % of GDP) in Oil in 2007 to that in 2009?
Your answer should be compact. 1.38. What is the ratio of the Mineral Rent(as % of GDP) in Other Minerals in 2007 to that in 2009?
Offer a very short reply. 1.75. What is the ratio of the Mineral Rent(as % of GDP) of Coal in 2007 to that in 2010?
Make the answer very short. 0.58. What is the ratio of the Mineral Rent(as % of GDP) of Natural Gas in 2007 to that in 2010?
Keep it short and to the point. 2.08. What is the ratio of the Mineral Rent(as % of GDP) of Oil in 2007 to that in 2010?
Ensure brevity in your answer.  1.13. What is the ratio of the Mineral Rent(as % of GDP) in Other Minerals in 2007 to that in 2010?
Your response must be concise. 1.2. What is the ratio of the Mineral Rent(as % of GDP) of Coal in 2007 to that in 2011?
Offer a very short reply. 0.41. What is the ratio of the Mineral Rent(as % of GDP) in Natural Gas in 2007 to that in 2011?
Your answer should be compact. 2.02. What is the ratio of the Mineral Rent(as % of GDP) in Oil in 2007 to that in 2011?
Your answer should be very brief. 1.03. What is the ratio of the Mineral Rent(as % of GDP) of Other Minerals in 2007 to that in 2011?
Keep it short and to the point. 1. What is the ratio of the Mineral Rent(as % of GDP) of Coal in 2007 to that in 2012?
Provide a succinct answer. 0.63. What is the ratio of the Mineral Rent(as % of GDP) in Natural Gas in 2007 to that in 2012?
Provide a short and direct response. 2.44. What is the ratio of the Mineral Rent(as % of GDP) of Oil in 2007 to that in 2012?
Keep it short and to the point. 0.91. What is the ratio of the Mineral Rent(as % of GDP) of Other Minerals in 2007 to that in 2012?
Give a very brief answer. 1.11. What is the ratio of the Mineral Rent(as % of GDP) of Coal in 2007 to that in 2013?
Make the answer very short. 0.95. What is the ratio of the Mineral Rent(as % of GDP) in Natural Gas in 2007 to that in 2013?
Make the answer very short. 2.49. What is the ratio of the Mineral Rent(as % of GDP) of Oil in 2007 to that in 2013?
Provide a short and direct response. 0.72. What is the ratio of the Mineral Rent(as % of GDP) of Other Minerals in 2007 to that in 2013?
Provide a short and direct response. 1.41. What is the ratio of the Mineral Rent(as % of GDP) in Coal in 2008 to that in 2009?
Your response must be concise. 3.36. What is the ratio of the Mineral Rent(as % of GDP) in Natural Gas in 2008 to that in 2009?
Provide a succinct answer. 1.97. What is the ratio of the Mineral Rent(as % of GDP) of Oil in 2008 to that in 2009?
Offer a very short reply. 1.61. What is the ratio of the Mineral Rent(as % of GDP) in Other Minerals in 2008 to that in 2009?
Your response must be concise. 1.19. What is the ratio of the Mineral Rent(as % of GDP) in Coal in 2008 to that in 2010?
Provide a short and direct response. 1.77. What is the ratio of the Mineral Rent(as % of GDP) of Natural Gas in 2008 to that in 2010?
Keep it short and to the point. 2.36. What is the ratio of the Mineral Rent(as % of GDP) of Oil in 2008 to that in 2010?
Your answer should be compact. 1.32. What is the ratio of the Mineral Rent(as % of GDP) in Other Minerals in 2008 to that in 2010?
Offer a very short reply. 0.82. What is the ratio of the Mineral Rent(as % of GDP) in Coal in 2008 to that in 2011?
Keep it short and to the point. 1.24. What is the ratio of the Mineral Rent(as % of GDP) in Natural Gas in 2008 to that in 2011?
Your answer should be very brief. 2.3. What is the ratio of the Mineral Rent(as % of GDP) in Oil in 2008 to that in 2011?
Your answer should be very brief. 1.21. What is the ratio of the Mineral Rent(as % of GDP) of Other Minerals in 2008 to that in 2011?
Provide a short and direct response. 0.68. What is the ratio of the Mineral Rent(as % of GDP) of Coal in 2008 to that in 2012?
Ensure brevity in your answer.  1.89. What is the ratio of the Mineral Rent(as % of GDP) of Natural Gas in 2008 to that in 2012?
Offer a very short reply. 2.77. What is the ratio of the Mineral Rent(as % of GDP) of Oil in 2008 to that in 2012?
Make the answer very short. 1.06. What is the ratio of the Mineral Rent(as % of GDP) of Other Minerals in 2008 to that in 2012?
Give a very brief answer. 0.75. What is the ratio of the Mineral Rent(as % of GDP) of Coal in 2008 to that in 2013?
Ensure brevity in your answer.  2.87. What is the ratio of the Mineral Rent(as % of GDP) of Natural Gas in 2008 to that in 2013?
Provide a succinct answer. 2.83. What is the ratio of the Mineral Rent(as % of GDP) of Oil in 2008 to that in 2013?
Your answer should be very brief. 0.84. What is the ratio of the Mineral Rent(as % of GDP) of Other Minerals in 2008 to that in 2013?
Your answer should be compact. 0.95. What is the ratio of the Mineral Rent(as % of GDP) in Coal in 2009 to that in 2010?
Give a very brief answer. 0.52. What is the ratio of the Mineral Rent(as % of GDP) of Natural Gas in 2009 to that in 2010?
Your answer should be compact. 1.2. What is the ratio of the Mineral Rent(as % of GDP) of Oil in 2009 to that in 2010?
Make the answer very short. 0.82. What is the ratio of the Mineral Rent(as % of GDP) of Other Minerals in 2009 to that in 2010?
Provide a succinct answer. 0.69. What is the ratio of the Mineral Rent(as % of GDP) in Coal in 2009 to that in 2011?
Your answer should be very brief. 0.37. What is the ratio of the Mineral Rent(as % of GDP) of Natural Gas in 2009 to that in 2011?
Provide a short and direct response. 1.17. What is the ratio of the Mineral Rent(as % of GDP) of Oil in 2009 to that in 2011?
Give a very brief answer. 0.75. What is the ratio of the Mineral Rent(as % of GDP) in Other Minerals in 2009 to that in 2011?
Provide a succinct answer. 0.57. What is the ratio of the Mineral Rent(as % of GDP) of Coal in 2009 to that in 2012?
Your response must be concise. 0.56. What is the ratio of the Mineral Rent(as % of GDP) of Natural Gas in 2009 to that in 2012?
Your response must be concise. 1.41. What is the ratio of the Mineral Rent(as % of GDP) in Oil in 2009 to that in 2012?
Keep it short and to the point. 0.66. What is the ratio of the Mineral Rent(as % of GDP) in Other Minerals in 2009 to that in 2012?
Provide a succinct answer. 0.63. What is the ratio of the Mineral Rent(as % of GDP) of Coal in 2009 to that in 2013?
Keep it short and to the point. 0.85. What is the ratio of the Mineral Rent(as % of GDP) in Natural Gas in 2009 to that in 2013?
Ensure brevity in your answer.  1.43. What is the ratio of the Mineral Rent(as % of GDP) of Oil in 2009 to that in 2013?
Your response must be concise. 0.52. What is the ratio of the Mineral Rent(as % of GDP) of Other Minerals in 2009 to that in 2013?
Offer a terse response. 0.8. What is the ratio of the Mineral Rent(as % of GDP) in Coal in 2010 to that in 2011?
Make the answer very short. 0.7. What is the ratio of the Mineral Rent(as % of GDP) in Natural Gas in 2010 to that in 2011?
Provide a succinct answer. 0.97. What is the ratio of the Mineral Rent(as % of GDP) of Oil in 2010 to that in 2011?
Your response must be concise. 0.91. What is the ratio of the Mineral Rent(as % of GDP) in Other Minerals in 2010 to that in 2011?
Offer a very short reply. 0.83. What is the ratio of the Mineral Rent(as % of GDP) in Coal in 2010 to that in 2012?
Offer a terse response. 1.07. What is the ratio of the Mineral Rent(as % of GDP) in Natural Gas in 2010 to that in 2012?
Your answer should be very brief. 1.17. What is the ratio of the Mineral Rent(as % of GDP) of Oil in 2010 to that in 2012?
Make the answer very short. 0.8. What is the ratio of the Mineral Rent(as % of GDP) in Other Minerals in 2010 to that in 2012?
Make the answer very short. 0.92. What is the ratio of the Mineral Rent(as % of GDP) of Coal in 2010 to that in 2013?
Offer a very short reply. 1.63. What is the ratio of the Mineral Rent(as % of GDP) of Natural Gas in 2010 to that in 2013?
Ensure brevity in your answer.  1.2. What is the ratio of the Mineral Rent(as % of GDP) in Oil in 2010 to that in 2013?
Your response must be concise. 0.63. What is the ratio of the Mineral Rent(as % of GDP) in Other Minerals in 2010 to that in 2013?
Offer a terse response. 1.17. What is the ratio of the Mineral Rent(as % of GDP) of Coal in 2011 to that in 2012?
Keep it short and to the point. 1.52. What is the ratio of the Mineral Rent(as % of GDP) of Natural Gas in 2011 to that in 2012?
Offer a very short reply. 1.21. What is the ratio of the Mineral Rent(as % of GDP) in Oil in 2011 to that in 2012?
Your answer should be compact. 0.88. What is the ratio of the Mineral Rent(as % of GDP) in Other Minerals in 2011 to that in 2012?
Make the answer very short. 1.12. What is the ratio of the Mineral Rent(as % of GDP) in Coal in 2011 to that in 2013?
Provide a succinct answer. 2.32. What is the ratio of the Mineral Rent(as % of GDP) of Natural Gas in 2011 to that in 2013?
Your answer should be very brief. 1.23. What is the ratio of the Mineral Rent(as % of GDP) of Oil in 2011 to that in 2013?
Your answer should be very brief. 0.69. What is the ratio of the Mineral Rent(as % of GDP) in Other Minerals in 2011 to that in 2013?
Make the answer very short. 1.41. What is the ratio of the Mineral Rent(as % of GDP) in Coal in 2012 to that in 2013?
Offer a very short reply. 1.52. What is the ratio of the Mineral Rent(as % of GDP) in Natural Gas in 2012 to that in 2013?
Your answer should be compact. 1.02. What is the ratio of the Mineral Rent(as % of GDP) of Oil in 2012 to that in 2013?
Your response must be concise. 0.79. What is the ratio of the Mineral Rent(as % of GDP) of Other Minerals in 2012 to that in 2013?
Keep it short and to the point. 1.26. What is the difference between the highest and the second highest Mineral Rent(as % of GDP) in Coal?
Your response must be concise. 0.23. What is the difference between the highest and the second highest Mineral Rent(as % of GDP) of Natural Gas?
Make the answer very short. 0.03. What is the difference between the highest and the second highest Mineral Rent(as % of GDP) in Oil?
Give a very brief answer. 0.02. What is the difference between the highest and the second highest Mineral Rent(as % of GDP) of Other Minerals?
Provide a succinct answer. 0. What is the difference between the highest and the lowest Mineral Rent(as % of GDP) in Coal?
Give a very brief answer. 0.82. What is the difference between the highest and the lowest Mineral Rent(as % of GDP) of Natural Gas?
Make the answer very short. 0.17. What is the difference between the highest and the lowest Mineral Rent(as % of GDP) in Oil?
Offer a very short reply. 0.05. What is the difference between the highest and the lowest Mineral Rent(as % of GDP) in Other Minerals?
Your answer should be very brief. 0.29. 